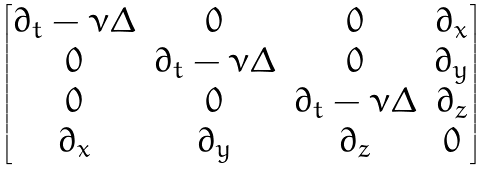<formula> <loc_0><loc_0><loc_500><loc_500>\begin{bmatrix} \partial _ { t } - \nu \Delta & 0 & 0 & \partial _ { x } \\ 0 & \partial _ { t } - \nu \Delta & 0 & \partial _ { y } \\ 0 & 0 & \partial _ { t } - \nu \Delta & \partial _ { z } \\ \partial _ { x } & \partial _ { y } & \partial _ { z } & 0 \end{bmatrix}</formula> 